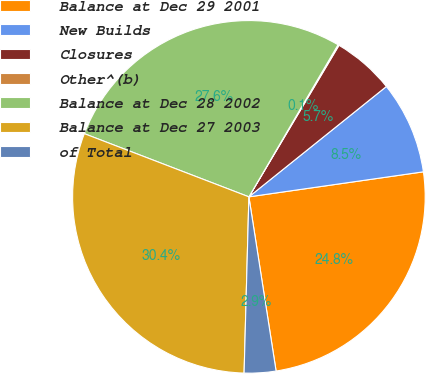Convert chart to OTSL. <chart><loc_0><loc_0><loc_500><loc_500><pie_chart><fcel>Balance at Dec 29 2001<fcel>New Builds<fcel>Closures<fcel>Other^(b)<fcel>Balance at Dec 28 2002<fcel>Balance at Dec 27 2003<fcel>of Total<nl><fcel>24.81%<fcel>8.5%<fcel>5.7%<fcel>0.1%<fcel>27.61%<fcel>30.41%<fcel>2.9%<nl></chart> 